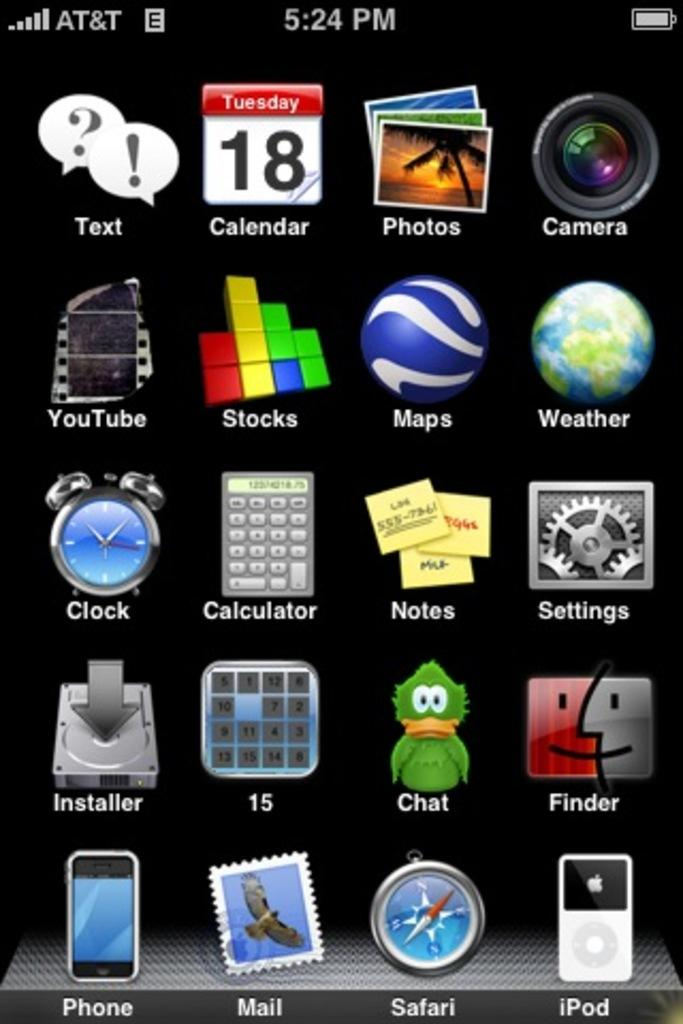<image>
Share a concise interpretation of the image provided. Screen for a phone which shows the app for iPod on the bottom right. 